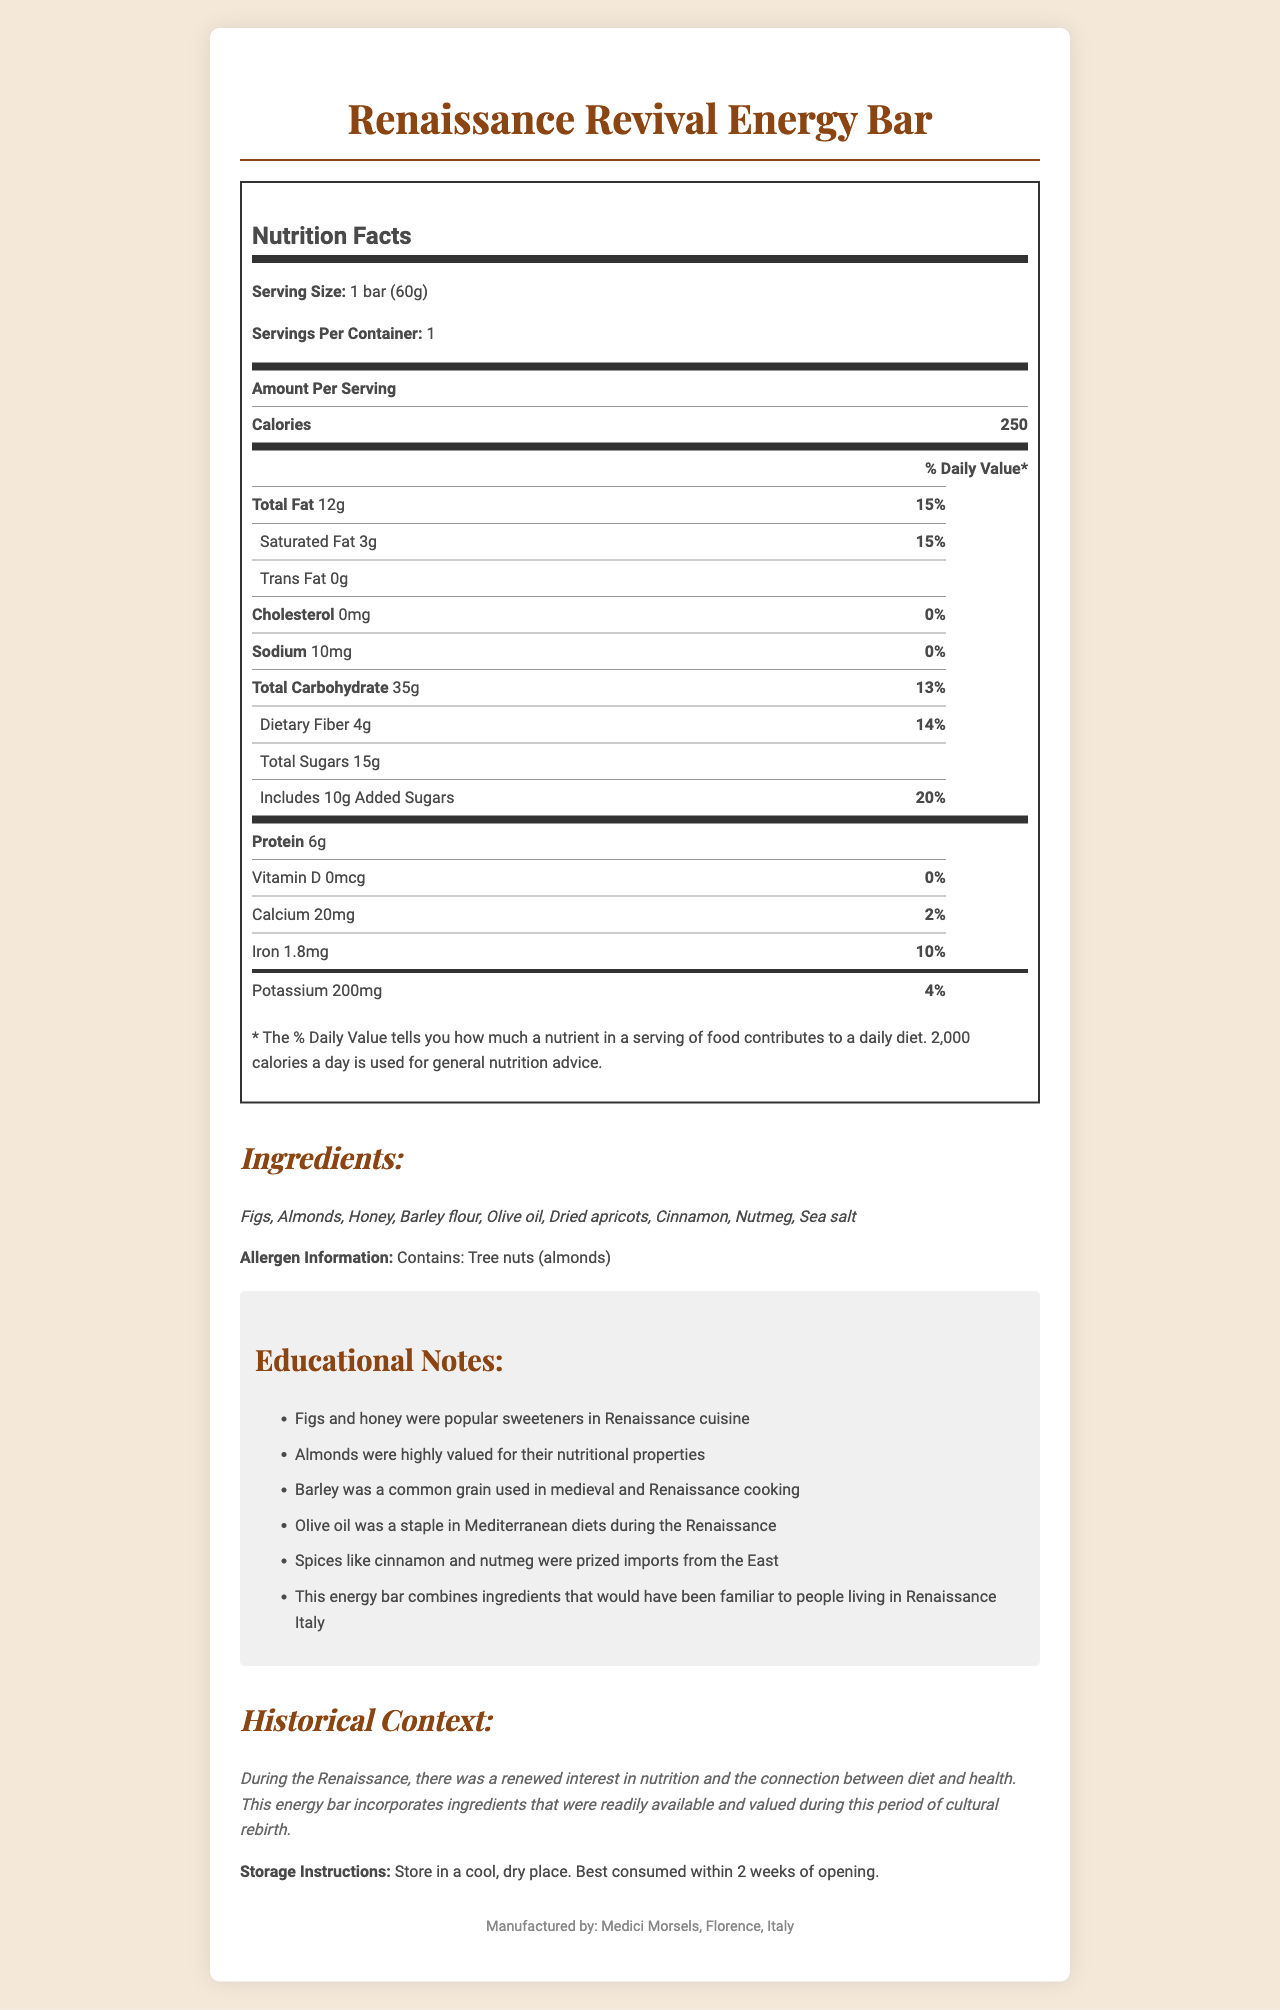what is the serving size of the Renaissance Revival Energy Bar? The serving size is clearly stated at the top of the nutrition facts label as "1 bar (60g)".
Answer: 1 bar (60g) How much total fat is in the energy bar? The amount of total fat is listed under the nutrition facts section as "Total Fat 12g".
Answer: 12g How many grams of protein does the energy bar contain? The nutrition facts label shows "Protein 6g" under the thick line of the table.
Answer: 6g What percentage of the daily value does the added sugars represent? It is shown in the nutrition facts label under added sugars as "Includes [10g] Added Sugars" with a daily value of "20%".
Answer: 20% What are the main ingredients in the Renaissance Revival Energy Bar? The ingredients list under the ingredients section provides these specifics.
Answer: Figs, Almonds, Honey, Barley flour, Olive oil, Dried apricots, Cinnamon, Nutmeg, Sea salt What were some sweeteners popular in Renaissance cuisine? A. Cane sugar B. Honey C. Maple syrup D. Corn syrup The educational notes specifically mention that figs and honey were popular sweeteners in Renaissance cuisine.
Answer: B Which grain was common in medieval and Renaissance cooking? 1. Wheat 2. Rice 3. Barley 4. Corn The educational notes mention that barley was a common grain used in medieval and Renaissance cooking.
Answer: 3 Does the Renaissance Revival Energy Bar contain any allergens? The allergen information states, "Contains: Tree nuts (almonds)".
Answer: Yes Is this energy bar suitable for someone with a tree nut allergy? The allergen information clearly states it contains tree nuts (almonds), making it unsuitable for someone with a tree nut allergy.
Answer: No Summarize the main idea of the document. The document highlights the balance of nutrition and historical significance by identifying ingredients and practices from the Renaissance period that are incorporated into the energy bar.
Answer: The Renaissance Revival Energy Bar is a snack inspired by ingredients known and valued during the Renaissance era. The document provides nutritional information, a list of ingredients, allergen information, historical context, and educational notes about Renaissance food practices. What is the exact amount of Vitamin C in the energy bar? The document does not mention Vitamin C content in the nutritional facts label.
Answer: Cannot be determined What is the historical significance of using olive oil in the energy bar? The educational notes under the document explain the use of each ingredient, with olive oil being noted as a staple in Mediterranean diets during the Renaissance.
Answer: Olive oil was a staple in Mediterranean diets during the Renaissance 